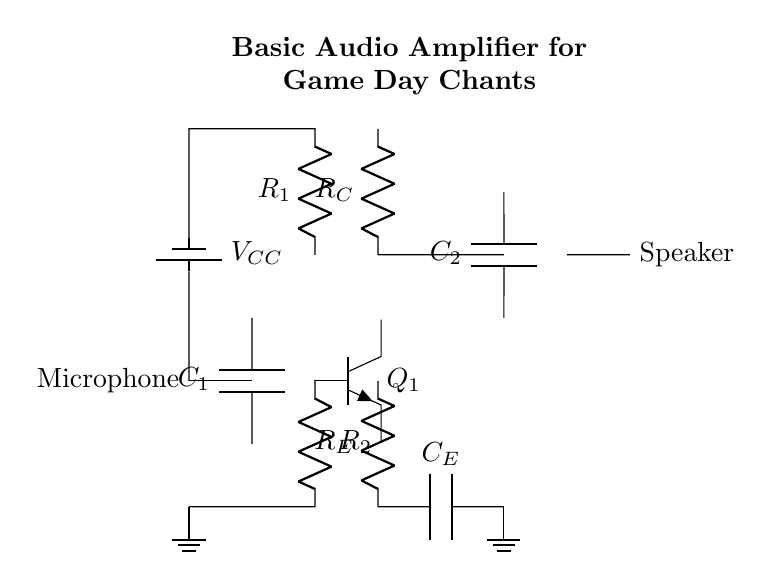What type of transistor is used in this circuit? The circuit diagram indicates the use of an NPN transistor, which is denoted by the symbol for the transistor labeled Q1. The configuration and labeling confirm its type.
Answer: NPN What is the purpose of capacitor C1? Capacitor C1 is typically used for coupling, which allows AC signals (such as audio) to pass while blocking DC signals. In this circuit, it connects the microphone output to the base of the transistor.
Answer: Coupling What is the value of the power supply voltage? The circuit specifies VCC, which is usually a standard value for power supplies; however, without specific labeling, we can infer it is usually 5V or higher for such circuits.
Answer: VCC How many resistors are present in this circuit? The diagram displays three unique resistor components (R1, R2, and RE). By counting these resistor labels in the circuit, you can clearly see the total number.
Answer: Three What is the role of the speaker in this circuit? The speaker is the load component, which converts the amplified audio signal from the output of the amplifier into sound. It receives the amplified output from the collector of the transistor.
Answer: Load What component is connected in parallel with the speaker? The output stage shows that capacitor C2 is connected in parallel with the speaker, providing a path for AC signals to pass effectively while blocking DC.
Answer: Capacitor C2 What does R_E do in this circuit? The emitter resistor RE helps stabilize the transistor's gain and sets the emitter current. It improves linearity and prevents distortion in the audio signal being amplified.
Answer: Stabilization 